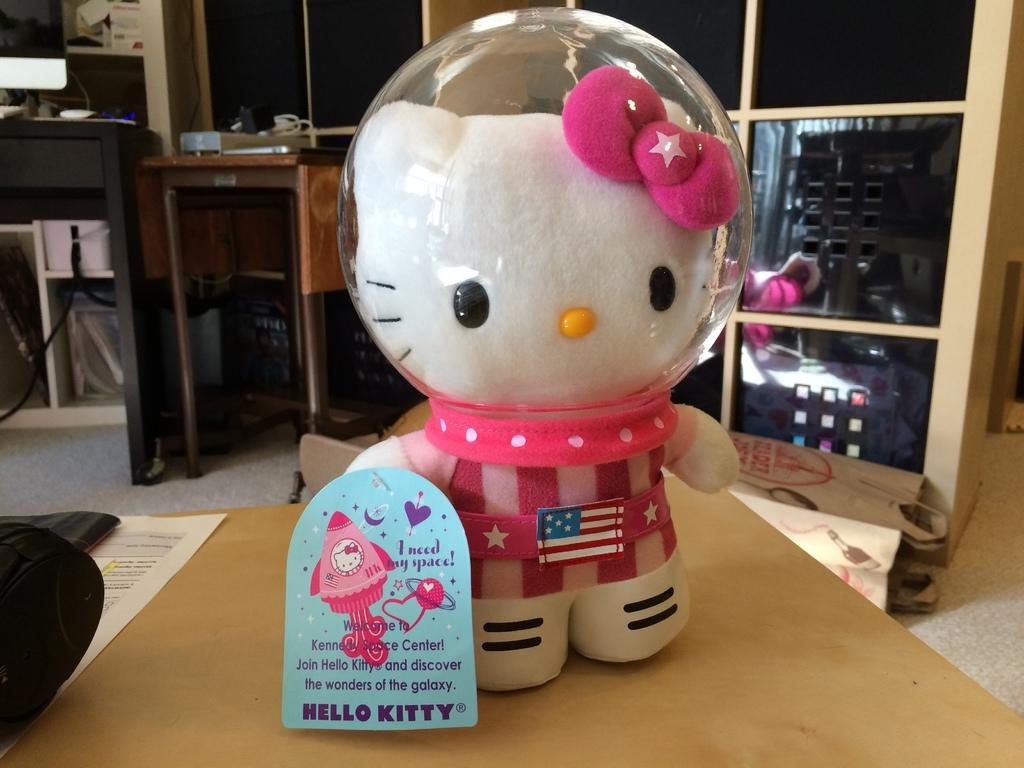What object is on the table in the image? There is a toy on the table in the image. What is located behind the toy on the table? There are tables behind the toy. What structure is visible behind the tables? There is a rack behind the toy. What type of store can be seen in the image? There is no store present in the image; it features a toy on a table with tables and a rack behind it. What kind of class is being held in the image? There is no class present in the image; it features a toy on a table with tables and a rack behind it. 